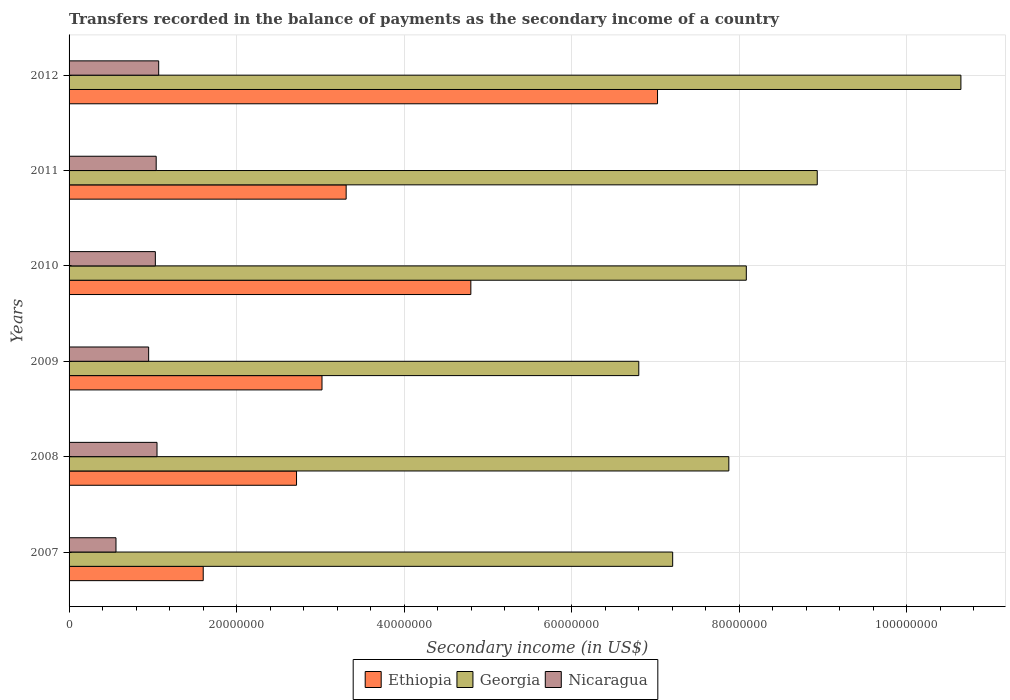How many groups of bars are there?
Provide a succinct answer. 6. Are the number of bars on each tick of the Y-axis equal?
Your answer should be very brief. Yes. How many bars are there on the 6th tick from the top?
Offer a terse response. 3. How many bars are there on the 1st tick from the bottom?
Your answer should be very brief. 3. What is the secondary income of in Ethiopia in 2008?
Offer a terse response. 2.72e+07. Across all years, what is the maximum secondary income of in Georgia?
Give a very brief answer. 1.06e+08. Across all years, what is the minimum secondary income of in Georgia?
Give a very brief answer. 6.80e+07. In which year was the secondary income of in Ethiopia minimum?
Provide a succinct answer. 2007. What is the total secondary income of in Georgia in the graph?
Provide a short and direct response. 4.95e+08. What is the difference between the secondary income of in Nicaragua in 2009 and that in 2012?
Your response must be concise. -1.20e+06. What is the difference between the secondary income of in Ethiopia in 2011 and the secondary income of in Nicaragua in 2012?
Your answer should be compact. 2.24e+07. What is the average secondary income of in Georgia per year?
Ensure brevity in your answer.  8.26e+07. In the year 2010, what is the difference between the secondary income of in Nicaragua and secondary income of in Georgia?
Make the answer very short. -7.06e+07. In how many years, is the secondary income of in Georgia greater than 20000000 US$?
Offer a terse response. 6. What is the ratio of the secondary income of in Nicaragua in 2007 to that in 2008?
Your response must be concise. 0.53. Is the difference between the secondary income of in Nicaragua in 2008 and 2009 greater than the difference between the secondary income of in Georgia in 2008 and 2009?
Provide a succinct answer. No. What is the difference between the highest and the lowest secondary income of in Ethiopia?
Ensure brevity in your answer.  5.42e+07. Is the sum of the secondary income of in Ethiopia in 2010 and 2011 greater than the maximum secondary income of in Georgia across all years?
Make the answer very short. No. What does the 3rd bar from the top in 2010 represents?
Your response must be concise. Ethiopia. What does the 2nd bar from the bottom in 2008 represents?
Make the answer very short. Georgia. Is it the case that in every year, the sum of the secondary income of in Georgia and secondary income of in Nicaragua is greater than the secondary income of in Ethiopia?
Your answer should be compact. Yes. How many years are there in the graph?
Your answer should be very brief. 6. Are the values on the major ticks of X-axis written in scientific E-notation?
Give a very brief answer. No. Does the graph contain any zero values?
Your answer should be compact. No. How are the legend labels stacked?
Give a very brief answer. Horizontal. What is the title of the graph?
Your answer should be compact. Transfers recorded in the balance of payments as the secondary income of a country. What is the label or title of the X-axis?
Your response must be concise. Secondary income (in US$). What is the label or title of the Y-axis?
Provide a succinct answer. Years. What is the Secondary income (in US$) in Ethiopia in 2007?
Provide a succinct answer. 1.60e+07. What is the Secondary income (in US$) of Georgia in 2007?
Provide a short and direct response. 7.21e+07. What is the Secondary income (in US$) of Nicaragua in 2007?
Make the answer very short. 5.60e+06. What is the Secondary income (in US$) of Ethiopia in 2008?
Your answer should be very brief. 2.72e+07. What is the Secondary income (in US$) of Georgia in 2008?
Offer a terse response. 7.88e+07. What is the Secondary income (in US$) in Nicaragua in 2008?
Your answer should be very brief. 1.05e+07. What is the Secondary income (in US$) in Ethiopia in 2009?
Give a very brief answer. 3.02e+07. What is the Secondary income (in US$) of Georgia in 2009?
Your answer should be very brief. 6.80e+07. What is the Secondary income (in US$) of Nicaragua in 2009?
Offer a terse response. 9.50e+06. What is the Secondary income (in US$) in Ethiopia in 2010?
Provide a short and direct response. 4.80e+07. What is the Secondary income (in US$) in Georgia in 2010?
Offer a very short reply. 8.09e+07. What is the Secondary income (in US$) in Nicaragua in 2010?
Make the answer very short. 1.03e+07. What is the Secondary income (in US$) in Ethiopia in 2011?
Offer a terse response. 3.31e+07. What is the Secondary income (in US$) of Georgia in 2011?
Provide a succinct answer. 8.93e+07. What is the Secondary income (in US$) in Nicaragua in 2011?
Your response must be concise. 1.04e+07. What is the Secondary income (in US$) of Ethiopia in 2012?
Ensure brevity in your answer.  7.03e+07. What is the Secondary income (in US$) in Georgia in 2012?
Offer a very short reply. 1.06e+08. What is the Secondary income (in US$) of Nicaragua in 2012?
Your response must be concise. 1.07e+07. Across all years, what is the maximum Secondary income (in US$) in Ethiopia?
Ensure brevity in your answer.  7.03e+07. Across all years, what is the maximum Secondary income (in US$) in Georgia?
Offer a very short reply. 1.06e+08. Across all years, what is the maximum Secondary income (in US$) of Nicaragua?
Your answer should be compact. 1.07e+07. Across all years, what is the minimum Secondary income (in US$) in Ethiopia?
Give a very brief answer. 1.60e+07. Across all years, what is the minimum Secondary income (in US$) in Georgia?
Keep it short and to the point. 6.80e+07. Across all years, what is the minimum Secondary income (in US$) in Nicaragua?
Your response must be concise. 5.60e+06. What is the total Secondary income (in US$) of Ethiopia in the graph?
Your answer should be compact. 2.25e+08. What is the total Secondary income (in US$) of Georgia in the graph?
Ensure brevity in your answer.  4.95e+08. What is the total Secondary income (in US$) of Nicaragua in the graph?
Make the answer very short. 5.70e+07. What is the difference between the Secondary income (in US$) of Ethiopia in 2007 and that in 2008?
Give a very brief answer. -1.11e+07. What is the difference between the Secondary income (in US$) of Georgia in 2007 and that in 2008?
Provide a succinct answer. -6.70e+06. What is the difference between the Secondary income (in US$) in Nicaragua in 2007 and that in 2008?
Ensure brevity in your answer.  -4.90e+06. What is the difference between the Secondary income (in US$) in Ethiopia in 2007 and that in 2009?
Provide a succinct answer. -1.42e+07. What is the difference between the Secondary income (in US$) of Georgia in 2007 and that in 2009?
Your answer should be very brief. 4.05e+06. What is the difference between the Secondary income (in US$) in Nicaragua in 2007 and that in 2009?
Your answer should be compact. -3.90e+06. What is the difference between the Secondary income (in US$) of Ethiopia in 2007 and that in 2010?
Your answer should be very brief. -3.20e+07. What is the difference between the Secondary income (in US$) in Georgia in 2007 and that in 2010?
Ensure brevity in your answer.  -8.79e+06. What is the difference between the Secondary income (in US$) in Nicaragua in 2007 and that in 2010?
Keep it short and to the point. -4.70e+06. What is the difference between the Secondary income (in US$) of Ethiopia in 2007 and that in 2011?
Offer a very short reply. -1.71e+07. What is the difference between the Secondary income (in US$) in Georgia in 2007 and that in 2011?
Make the answer very short. -1.73e+07. What is the difference between the Secondary income (in US$) in Nicaragua in 2007 and that in 2011?
Offer a very short reply. -4.80e+06. What is the difference between the Secondary income (in US$) of Ethiopia in 2007 and that in 2012?
Ensure brevity in your answer.  -5.42e+07. What is the difference between the Secondary income (in US$) in Georgia in 2007 and that in 2012?
Your answer should be very brief. -3.44e+07. What is the difference between the Secondary income (in US$) in Nicaragua in 2007 and that in 2012?
Give a very brief answer. -5.10e+06. What is the difference between the Secondary income (in US$) of Ethiopia in 2008 and that in 2009?
Offer a terse response. -3.04e+06. What is the difference between the Secondary income (in US$) of Georgia in 2008 and that in 2009?
Your answer should be compact. 1.08e+07. What is the difference between the Secondary income (in US$) of Nicaragua in 2008 and that in 2009?
Keep it short and to the point. 1.00e+06. What is the difference between the Secondary income (in US$) in Ethiopia in 2008 and that in 2010?
Your response must be concise. -2.08e+07. What is the difference between the Secondary income (in US$) in Georgia in 2008 and that in 2010?
Your answer should be compact. -2.09e+06. What is the difference between the Secondary income (in US$) of Nicaragua in 2008 and that in 2010?
Offer a very short reply. 2.00e+05. What is the difference between the Secondary income (in US$) of Ethiopia in 2008 and that in 2011?
Provide a succinct answer. -5.93e+06. What is the difference between the Secondary income (in US$) of Georgia in 2008 and that in 2011?
Offer a terse response. -1.06e+07. What is the difference between the Secondary income (in US$) of Ethiopia in 2008 and that in 2012?
Your answer should be very brief. -4.31e+07. What is the difference between the Secondary income (in US$) of Georgia in 2008 and that in 2012?
Your answer should be very brief. -2.77e+07. What is the difference between the Secondary income (in US$) of Nicaragua in 2008 and that in 2012?
Provide a succinct answer. -2.00e+05. What is the difference between the Secondary income (in US$) in Ethiopia in 2009 and that in 2010?
Give a very brief answer. -1.78e+07. What is the difference between the Secondary income (in US$) in Georgia in 2009 and that in 2010?
Your answer should be compact. -1.28e+07. What is the difference between the Secondary income (in US$) in Nicaragua in 2009 and that in 2010?
Provide a short and direct response. -8.00e+05. What is the difference between the Secondary income (in US$) in Ethiopia in 2009 and that in 2011?
Provide a short and direct response. -2.88e+06. What is the difference between the Secondary income (in US$) in Georgia in 2009 and that in 2011?
Provide a succinct answer. -2.13e+07. What is the difference between the Secondary income (in US$) of Nicaragua in 2009 and that in 2011?
Your answer should be compact. -9.00e+05. What is the difference between the Secondary income (in US$) in Ethiopia in 2009 and that in 2012?
Your answer should be compact. -4.01e+07. What is the difference between the Secondary income (in US$) of Georgia in 2009 and that in 2012?
Your response must be concise. -3.85e+07. What is the difference between the Secondary income (in US$) of Nicaragua in 2009 and that in 2012?
Provide a short and direct response. -1.20e+06. What is the difference between the Secondary income (in US$) of Ethiopia in 2010 and that in 2011?
Offer a terse response. 1.49e+07. What is the difference between the Secondary income (in US$) in Georgia in 2010 and that in 2011?
Provide a succinct answer. -8.47e+06. What is the difference between the Secondary income (in US$) in Nicaragua in 2010 and that in 2011?
Your response must be concise. -1.00e+05. What is the difference between the Secondary income (in US$) of Ethiopia in 2010 and that in 2012?
Offer a terse response. -2.23e+07. What is the difference between the Secondary income (in US$) of Georgia in 2010 and that in 2012?
Your response must be concise. -2.56e+07. What is the difference between the Secondary income (in US$) of Nicaragua in 2010 and that in 2012?
Provide a short and direct response. -4.00e+05. What is the difference between the Secondary income (in US$) in Ethiopia in 2011 and that in 2012?
Make the answer very short. -3.72e+07. What is the difference between the Secondary income (in US$) of Georgia in 2011 and that in 2012?
Make the answer very short. -1.71e+07. What is the difference between the Secondary income (in US$) in Nicaragua in 2011 and that in 2012?
Offer a terse response. -3.00e+05. What is the difference between the Secondary income (in US$) in Ethiopia in 2007 and the Secondary income (in US$) in Georgia in 2008?
Keep it short and to the point. -6.28e+07. What is the difference between the Secondary income (in US$) of Ethiopia in 2007 and the Secondary income (in US$) of Nicaragua in 2008?
Your answer should be compact. 5.52e+06. What is the difference between the Secondary income (in US$) in Georgia in 2007 and the Secondary income (in US$) in Nicaragua in 2008?
Provide a short and direct response. 6.16e+07. What is the difference between the Secondary income (in US$) of Ethiopia in 2007 and the Secondary income (in US$) of Georgia in 2009?
Provide a succinct answer. -5.20e+07. What is the difference between the Secondary income (in US$) of Ethiopia in 2007 and the Secondary income (in US$) of Nicaragua in 2009?
Give a very brief answer. 6.52e+06. What is the difference between the Secondary income (in US$) in Georgia in 2007 and the Secondary income (in US$) in Nicaragua in 2009?
Your answer should be very brief. 6.26e+07. What is the difference between the Secondary income (in US$) of Ethiopia in 2007 and the Secondary income (in US$) of Georgia in 2010?
Offer a terse response. -6.48e+07. What is the difference between the Secondary income (in US$) of Ethiopia in 2007 and the Secondary income (in US$) of Nicaragua in 2010?
Make the answer very short. 5.72e+06. What is the difference between the Secondary income (in US$) in Georgia in 2007 and the Secondary income (in US$) in Nicaragua in 2010?
Give a very brief answer. 6.18e+07. What is the difference between the Secondary income (in US$) of Ethiopia in 2007 and the Secondary income (in US$) of Georgia in 2011?
Make the answer very short. -7.33e+07. What is the difference between the Secondary income (in US$) of Ethiopia in 2007 and the Secondary income (in US$) of Nicaragua in 2011?
Keep it short and to the point. 5.62e+06. What is the difference between the Secondary income (in US$) of Georgia in 2007 and the Secondary income (in US$) of Nicaragua in 2011?
Keep it short and to the point. 6.17e+07. What is the difference between the Secondary income (in US$) in Ethiopia in 2007 and the Secondary income (in US$) in Georgia in 2012?
Provide a short and direct response. -9.05e+07. What is the difference between the Secondary income (in US$) in Ethiopia in 2007 and the Secondary income (in US$) in Nicaragua in 2012?
Give a very brief answer. 5.32e+06. What is the difference between the Secondary income (in US$) in Georgia in 2007 and the Secondary income (in US$) in Nicaragua in 2012?
Ensure brevity in your answer.  6.14e+07. What is the difference between the Secondary income (in US$) of Ethiopia in 2008 and the Secondary income (in US$) of Georgia in 2009?
Keep it short and to the point. -4.09e+07. What is the difference between the Secondary income (in US$) in Ethiopia in 2008 and the Secondary income (in US$) in Nicaragua in 2009?
Your answer should be compact. 1.77e+07. What is the difference between the Secondary income (in US$) in Georgia in 2008 and the Secondary income (in US$) in Nicaragua in 2009?
Your answer should be very brief. 6.93e+07. What is the difference between the Secondary income (in US$) in Ethiopia in 2008 and the Secondary income (in US$) in Georgia in 2010?
Give a very brief answer. -5.37e+07. What is the difference between the Secondary income (in US$) of Ethiopia in 2008 and the Secondary income (in US$) of Nicaragua in 2010?
Ensure brevity in your answer.  1.69e+07. What is the difference between the Secondary income (in US$) in Georgia in 2008 and the Secondary income (in US$) in Nicaragua in 2010?
Give a very brief answer. 6.85e+07. What is the difference between the Secondary income (in US$) of Ethiopia in 2008 and the Secondary income (in US$) of Georgia in 2011?
Provide a short and direct response. -6.22e+07. What is the difference between the Secondary income (in US$) of Ethiopia in 2008 and the Secondary income (in US$) of Nicaragua in 2011?
Make the answer very short. 1.68e+07. What is the difference between the Secondary income (in US$) in Georgia in 2008 and the Secondary income (in US$) in Nicaragua in 2011?
Give a very brief answer. 6.84e+07. What is the difference between the Secondary income (in US$) of Ethiopia in 2008 and the Secondary income (in US$) of Georgia in 2012?
Your answer should be very brief. -7.93e+07. What is the difference between the Secondary income (in US$) of Ethiopia in 2008 and the Secondary income (in US$) of Nicaragua in 2012?
Keep it short and to the point. 1.65e+07. What is the difference between the Secondary income (in US$) in Georgia in 2008 and the Secondary income (in US$) in Nicaragua in 2012?
Give a very brief answer. 6.81e+07. What is the difference between the Secondary income (in US$) in Ethiopia in 2009 and the Secondary income (in US$) in Georgia in 2010?
Offer a terse response. -5.07e+07. What is the difference between the Secondary income (in US$) in Ethiopia in 2009 and the Secondary income (in US$) in Nicaragua in 2010?
Your response must be concise. 1.99e+07. What is the difference between the Secondary income (in US$) of Georgia in 2009 and the Secondary income (in US$) of Nicaragua in 2010?
Make the answer very short. 5.77e+07. What is the difference between the Secondary income (in US$) of Ethiopia in 2009 and the Secondary income (in US$) of Georgia in 2011?
Provide a succinct answer. -5.91e+07. What is the difference between the Secondary income (in US$) in Ethiopia in 2009 and the Secondary income (in US$) in Nicaragua in 2011?
Your answer should be very brief. 1.98e+07. What is the difference between the Secondary income (in US$) of Georgia in 2009 and the Secondary income (in US$) of Nicaragua in 2011?
Give a very brief answer. 5.76e+07. What is the difference between the Secondary income (in US$) of Ethiopia in 2009 and the Secondary income (in US$) of Georgia in 2012?
Make the answer very short. -7.63e+07. What is the difference between the Secondary income (in US$) of Ethiopia in 2009 and the Secondary income (in US$) of Nicaragua in 2012?
Give a very brief answer. 1.95e+07. What is the difference between the Secondary income (in US$) of Georgia in 2009 and the Secondary income (in US$) of Nicaragua in 2012?
Your answer should be very brief. 5.73e+07. What is the difference between the Secondary income (in US$) of Ethiopia in 2010 and the Secondary income (in US$) of Georgia in 2011?
Offer a terse response. -4.14e+07. What is the difference between the Secondary income (in US$) of Ethiopia in 2010 and the Secondary income (in US$) of Nicaragua in 2011?
Ensure brevity in your answer.  3.76e+07. What is the difference between the Secondary income (in US$) in Georgia in 2010 and the Secondary income (in US$) in Nicaragua in 2011?
Your answer should be compact. 7.05e+07. What is the difference between the Secondary income (in US$) of Ethiopia in 2010 and the Secondary income (in US$) of Georgia in 2012?
Your answer should be very brief. -5.85e+07. What is the difference between the Secondary income (in US$) of Ethiopia in 2010 and the Secondary income (in US$) of Nicaragua in 2012?
Your response must be concise. 3.73e+07. What is the difference between the Secondary income (in US$) in Georgia in 2010 and the Secondary income (in US$) in Nicaragua in 2012?
Provide a succinct answer. 7.02e+07. What is the difference between the Secondary income (in US$) in Ethiopia in 2011 and the Secondary income (in US$) in Georgia in 2012?
Give a very brief answer. -7.34e+07. What is the difference between the Secondary income (in US$) of Ethiopia in 2011 and the Secondary income (in US$) of Nicaragua in 2012?
Your answer should be compact. 2.24e+07. What is the difference between the Secondary income (in US$) of Georgia in 2011 and the Secondary income (in US$) of Nicaragua in 2012?
Your answer should be compact. 7.86e+07. What is the average Secondary income (in US$) in Ethiopia per year?
Offer a terse response. 3.74e+07. What is the average Secondary income (in US$) of Georgia per year?
Your response must be concise. 8.26e+07. What is the average Secondary income (in US$) in Nicaragua per year?
Your answer should be very brief. 9.50e+06. In the year 2007, what is the difference between the Secondary income (in US$) in Ethiopia and Secondary income (in US$) in Georgia?
Give a very brief answer. -5.60e+07. In the year 2007, what is the difference between the Secondary income (in US$) of Ethiopia and Secondary income (in US$) of Nicaragua?
Your answer should be very brief. 1.04e+07. In the year 2007, what is the difference between the Secondary income (in US$) in Georgia and Secondary income (in US$) in Nicaragua?
Ensure brevity in your answer.  6.65e+07. In the year 2008, what is the difference between the Secondary income (in US$) in Ethiopia and Secondary income (in US$) in Georgia?
Provide a short and direct response. -5.16e+07. In the year 2008, what is the difference between the Secondary income (in US$) in Ethiopia and Secondary income (in US$) in Nicaragua?
Offer a terse response. 1.67e+07. In the year 2008, what is the difference between the Secondary income (in US$) of Georgia and Secondary income (in US$) of Nicaragua?
Give a very brief answer. 6.83e+07. In the year 2009, what is the difference between the Secondary income (in US$) of Ethiopia and Secondary income (in US$) of Georgia?
Give a very brief answer. -3.78e+07. In the year 2009, what is the difference between the Secondary income (in US$) of Ethiopia and Secondary income (in US$) of Nicaragua?
Provide a succinct answer. 2.07e+07. In the year 2009, what is the difference between the Secondary income (in US$) of Georgia and Secondary income (in US$) of Nicaragua?
Provide a succinct answer. 5.85e+07. In the year 2010, what is the difference between the Secondary income (in US$) of Ethiopia and Secondary income (in US$) of Georgia?
Offer a terse response. -3.29e+07. In the year 2010, what is the difference between the Secondary income (in US$) of Ethiopia and Secondary income (in US$) of Nicaragua?
Provide a short and direct response. 3.77e+07. In the year 2010, what is the difference between the Secondary income (in US$) in Georgia and Secondary income (in US$) in Nicaragua?
Ensure brevity in your answer.  7.06e+07. In the year 2011, what is the difference between the Secondary income (in US$) of Ethiopia and Secondary income (in US$) of Georgia?
Keep it short and to the point. -5.62e+07. In the year 2011, what is the difference between the Secondary income (in US$) in Ethiopia and Secondary income (in US$) in Nicaragua?
Provide a succinct answer. 2.27e+07. In the year 2011, what is the difference between the Secondary income (in US$) of Georgia and Secondary income (in US$) of Nicaragua?
Provide a short and direct response. 7.89e+07. In the year 2012, what is the difference between the Secondary income (in US$) of Ethiopia and Secondary income (in US$) of Georgia?
Give a very brief answer. -3.62e+07. In the year 2012, what is the difference between the Secondary income (in US$) of Ethiopia and Secondary income (in US$) of Nicaragua?
Your response must be concise. 5.96e+07. In the year 2012, what is the difference between the Secondary income (in US$) in Georgia and Secondary income (in US$) in Nicaragua?
Give a very brief answer. 9.58e+07. What is the ratio of the Secondary income (in US$) of Ethiopia in 2007 to that in 2008?
Provide a short and direct response. 0.59. What is the ratio of the Secondary income (in US$) in Georgia in 2007 to that in 2008?
Offer a terse response. 0.91. What is the ratio of the Secondary income (in US$) in Nicaragua in 2007 to that in 2008?
Keep it short and to the point. 0.53. What is the ratio of the Secondary income (in US$) of Ethiopia in 2007 to that in 2009?
Ensure brevity in your answer.  0.53. What is the ratio of the Secondary income (in US$) in Georgia in 2007 to that in 2009?
Provide a succinct answer. 1.06. What is the ratio of the Secondary income (in US$) of Nicaragua in 2007 to that in 2009?
Offer a very short reply. 0.59. What is the ratio of the Secondary income (in US$) of Ethiopia in 2007 to that in 2010?
Provide a succinct answer. 0.33. What is the ratio of the Secondary income (in US$) of Georgia in 2007 to that in 2010?
Offer a very short reply. 0.89. What is the ratio of the Secondary income (in US$) of Nicaragua in 2007 to that in 2010?
Provide a short and direct response. 0.54. What is the ratio of the Secondary income (in US$) of Ethiopia in 2007 to that in 2011?
Make the answer very short. 0.48. What is the ratio of the Secondary income (in US$) in Georgia in 2007 to that in 2011?
Your answer should be compact. 0.81. What is the ratio of the Secondary income (in US$) of Nicaragua in 2007 to that in 2011?
Offer a very short reply. 0.54. What is the ratio of the Secondary income (in US$) in Ethiopia in 2007 to that in 2012?
Your answer should be compact. 0.23. What is the ratio of the Secondary income (in US$) of Georgia in 2007 to that in 2012?
Provide a succinct answer. 0.68. What is the ratio of the Secondary income (in US$) of Nicaragua in 2007 to that in 2012?
Give a very brief answer. 0.52. What is the ratio of the Secondary income (in US$) of Ethiopia in 2008 to that in 2009?
Make the answer very short. 0.9. What is the ratio of the Secondary income (in US$) in Georgia in 2008 to that in 2009?
Provide a succinct answer. 1.16. What is the ratio of the Secondary income (in US$) in Nicaragua in 2008 to that in 2009?
Make the answer very short. 1.11. What is the ratio of the Secondary income (in US$) in Ethiopia in 2008 to that in 2010?
Offer a terse response. 0.57. What is the ratio of the Secondary income (in US$) of Georgia in 2008 to that in 2010?
Offer a terse response. 0.97. What is the ratio of the Secondary income (in US$) in Nicaragua in 2008 to that in 2010?
Your answer should be compact. 1.02. What is the ratio of the Secondary income (in US$) in Ethiopia in 2008 to that in 2011?
Give a very brief answer. 0.82. What is the ratio of the Secondary income (in US$) in Georgia in 2008 to that in 2011?
Offer a terse response. 0.88. What is the ratio of the Secondary income (in US$) of Nicaragua in 2008 to that in 2011?
Your answer should be very brief. 1.01. What is the ratio of the Secondary income (in US$) of Ethiopia in 2008 to that in 2012?
Provide a short and direct response. 0.39. What is the ratio of the Secondary income (in US$) of Georgia in 2008 to that in 2012?
Give a very brief answer. 0.74. What is the ratio of the Secondary income (in US$) of Nicaragua in 2008 to that in 2012?
Provide a succinct answer. 0.98. What is the ratio of the Secondary income (in US$) of Ethiopia in 2009 to that in 2010?
Your answer should be very brief. 0.63. What is the ratio of the Secondary income (in US$) of Georgia in 2009 to that in 2010?
Offer a very short reply. 0.84. What is the ratio of the Secondary income (in US$) in Nicaragua in 2009 to that in 2010?
Make the answer very short. 0.92. What is the ratio of the Secondary income (in US$) of Ethiopia in 2009 to that in 2011?
Give a very brief answer. 0.91. What is the ratio of the Secondary income (in US$) of Georgia in 2009 to that in 2011?
Your response must be concise. 0.76. What is the ratio of the Secondary income (in US$) of Nicaragua in 2009 to that in 2011?
Provide a short and direct response. 0.91. What is the ratio of the Secondary income (in US$) in Ethiopia in 2009 to that in 2012?
Offer a terse response. 0.43. What is the ratio of the Secondary income (in US$) in Georgia in 2009 to that in 2012?
Offer a very short reply. 0.64. What is the ratio of the Secondary income (in US$) in Nicaragua in 2009 to that in 2012?
Your answer should be very brief. 0.89. What is the ratio of the Secondary income (in US$) in Ethiopia in 2010 to that in 2011?
Provide a succinct answer. 1.45. What is the ratio of the Secondary income (in US$) of Georgia in 2010 to that in 2011?
Make the answer very short. 0.91. What is the ratio of the Secondary income (in US$) in Ethiopia in 2010 to that in 2012?
Provide a short and direct response. 0.68. What is the ratio of the Secondary income (in US$) of Georgia in 2010 to that in 2012?
Provide a short and direct response. 0.76. What is the ratio of the Secondary income (in US$) of Nicaragua in 2010 to that in 2012?
Offer a terse response. 0.96. What is the ratio of the Secondary income (in US$) in Ethiopia in 2011 to that in 2012?
Keep it short and to the point. 0.47. What is the ratio of the Secondary income (in US$) in Georgia in 2011 to that in 2012?
Provide a succinct answer. 0.84. What is the difference between the highest and the second highest Secondary income (in US$) of Ethiopia?
Provide a succinct answer. 2.23e+07. What is the difference between the highest and the second highest Secondary income (in US$) in Georgia?
Make the answer very short. 1.71e+07. What is the difference between the highest and the second highest Secondary income (in US$) of Nicaragua?
Give a very brief answer. 2.00e+05. What is the difference between the highest and the lowest Secondary income (in US$) of Ethiopia?
Offer a very short reply. 5.42e+07. What is the difference between the highest and the lowest Secondary income (in US$) in Georgia?
Your answer should be very brief. 3.85e+07. What is the difference between the highest and the lowest Secondary income (in US$) in Nicaragua?
Your response must be concise. 5.10e+06. 